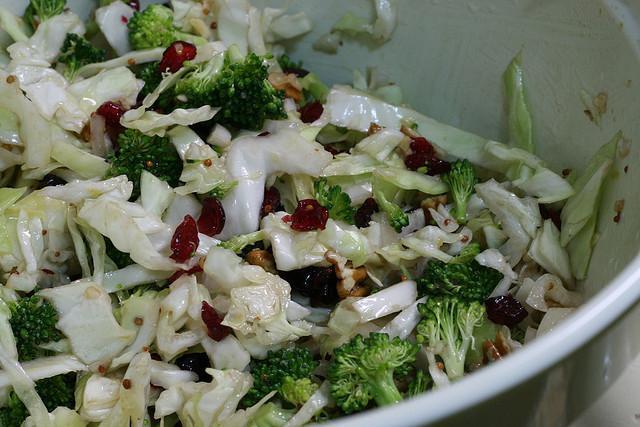How many broccolis are there?
Give a very brief answer. 5. How many people on the horse?
Give a very brief answer. 0. 